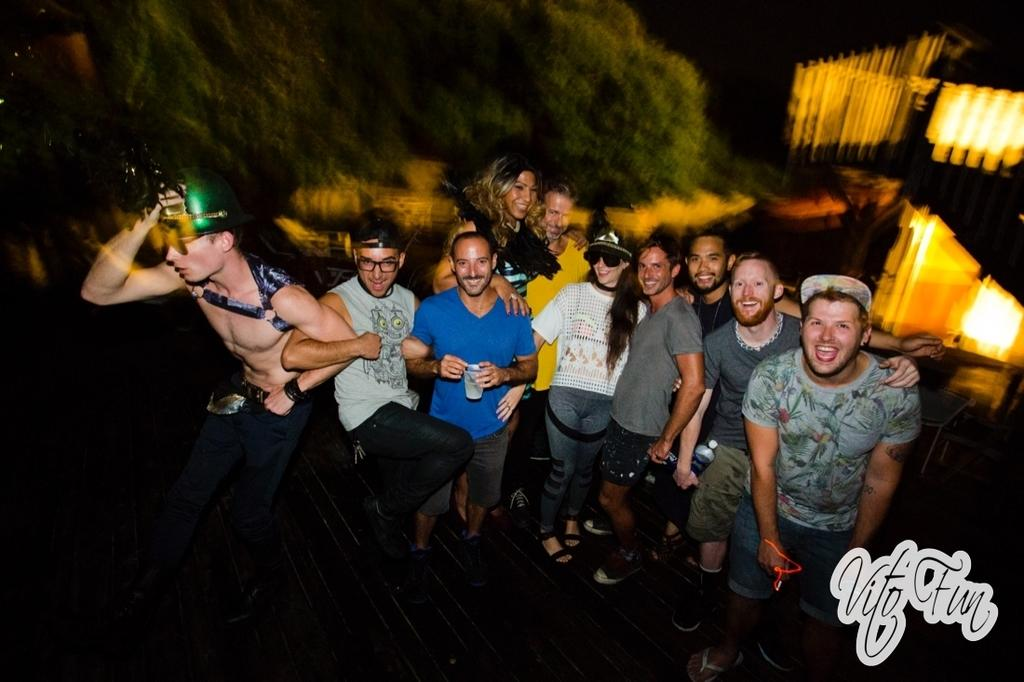How many people are in the image? There are multiple people in the image. What are the people in the image doing? The people are standing in a group, some are smiling, a few are dancing, and one person is holding a glass with a drink. What type of chicken is being pointed at with a rake in the image? There is no chicken or rake present in the image. 